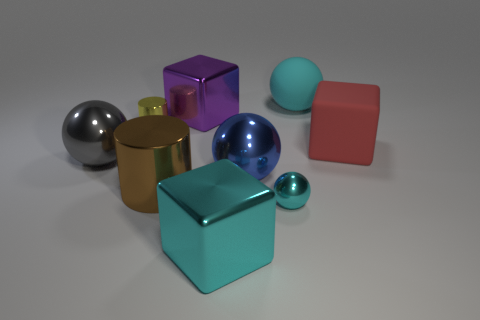Is the number of cyan spheres in front of the red matte cube greater than the number of small blue matte balls?
Keep it short and to the point. Yes. The big block in front of the thing right of the large cyan thing that is behind the big red rubber block is made of what material?
Make the answer very short. Metal. What number of things are either tiny cyan things or large shiny objects to the right of the small cylinder?
Offer a terse response. 5. There is a sphere that is behind the gray metal sphere; does it have the same color as the small ball?
Keep it short and to the point. Yes. Is the number of cyan objects to the right of the blue metal thing greater than the number of big red things in front of the red matte block?
Your answer should be very brief. Yes. Are there any other things of the same color as the small metallic cylinder?
Provide a succinct answer. No. How many things are large matte things or metal cubes?
Your answer should be compact. 4. Is the size of the cylinder in front of the red block the same as the large cyan matte object?
Offer a very short reply. Yes. What number of other objects are the same size as the gray metallic object?
Ensure brevity in your answer.  6. Is there a small shiny object?
Your answer should be compact. Yes. 